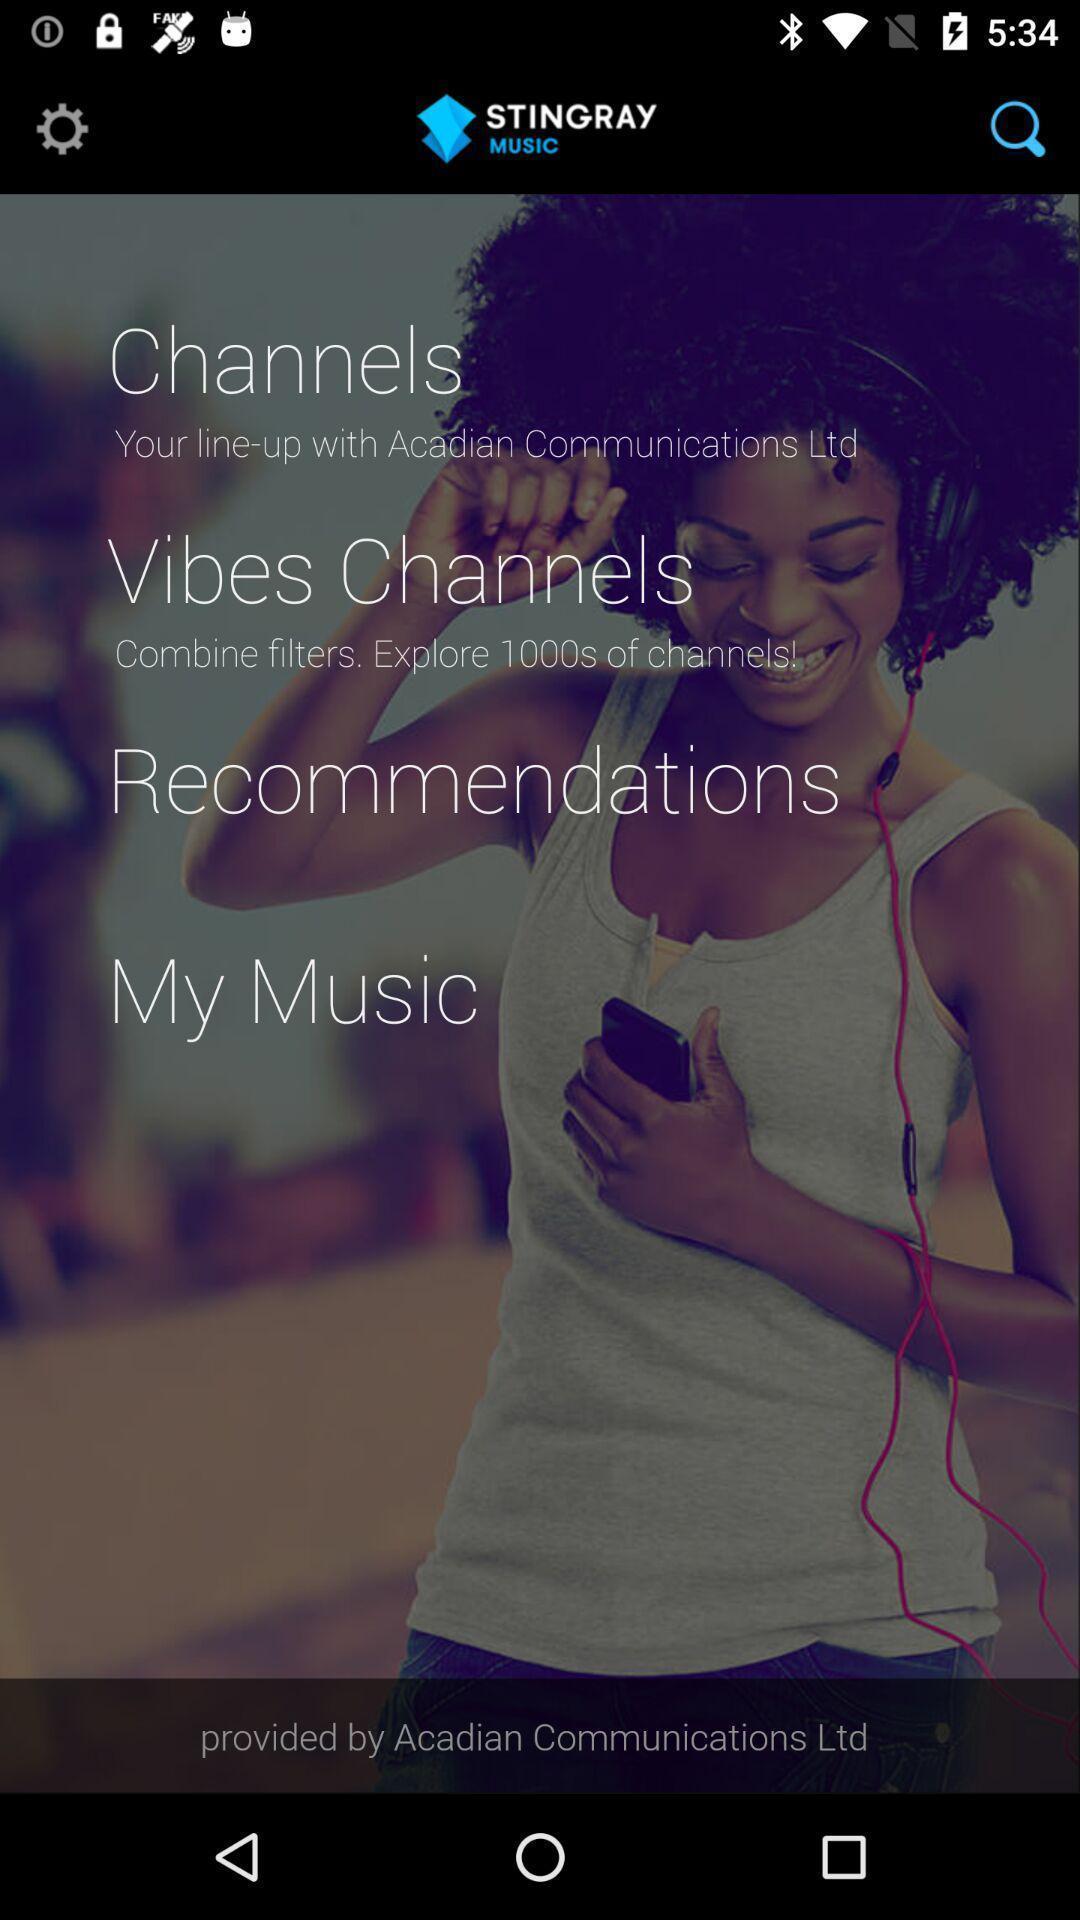Describe the content in this image. Welcome page of a music app. 